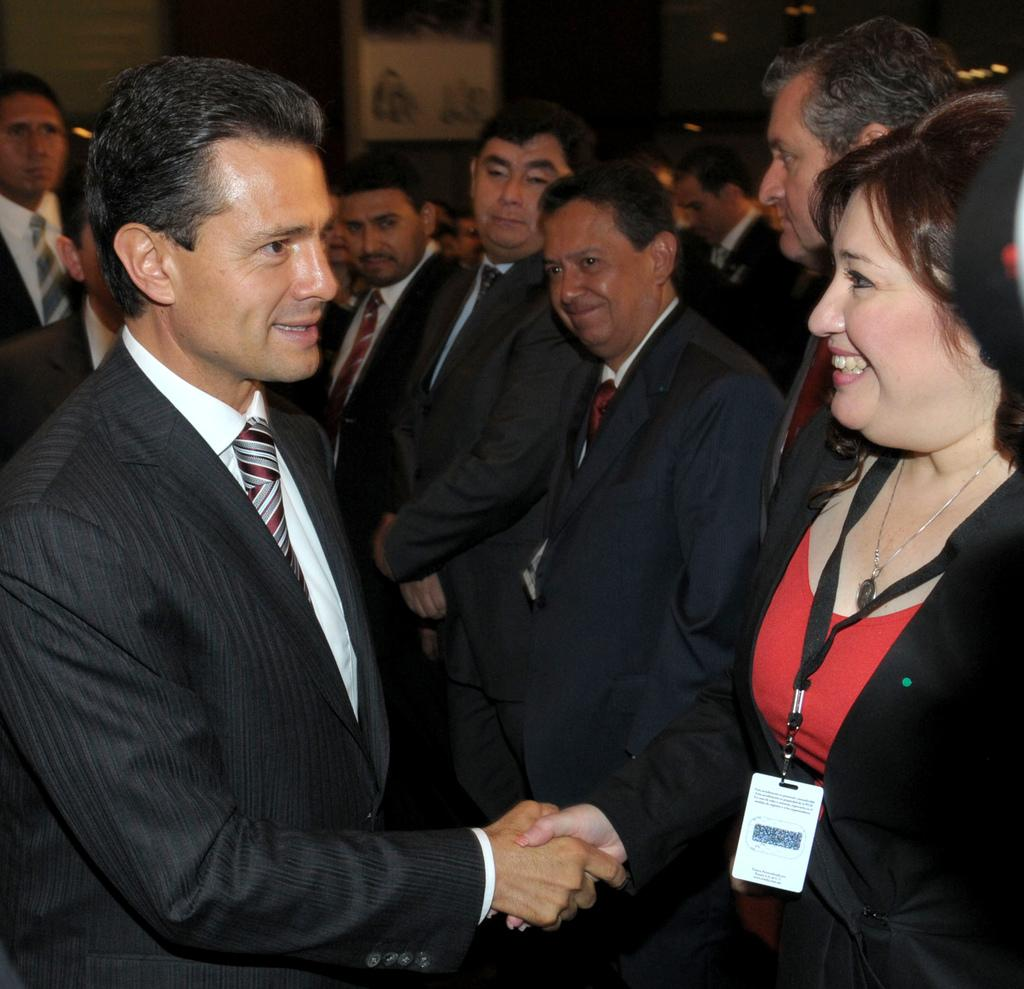What is happening in the image involving the people? There are people standing in the image, and a woman is shaking hands with a man. Can you describe any specific details about the woman in the image? The woman is wearing an ID card. What type of flame can be seen in the image? There is no flame present in the image. What riddle is being solved by the people in the image? There is no riddle being solved in the image; the people are shaking hands. 